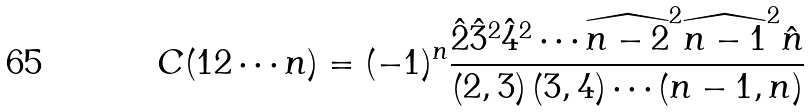Convert formula to latex. <formula><loc_0><loc_0><loc_500><loc_500>C ( 1 2 \cdots n ) = ( - 1 ) ^ { n } \frac { \hat { 2 } \hat { 3 } ^ { 2 } \hat { 4 } ^ { 2 } \cdots \widehat { n - 2 } ^ { 2 } \widehat { n - 1 } ^ { 2 } \hat { n } } { \left ( 2 , 3 \right ) \left ( 3 , 4 \right ) \cdots \left ( n - 1 , n \right ) }</formula> 